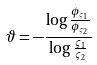Convert formula to latex. <formula><loc_0><loc_0><loc_500><loc_500>\vartheta = - \frac { \log \frac { \phi _ { \varsigma _ { 1 } } } { \phi _ { \varsigma _ { 2 } } } } { \log \frac { \varsigma _ { 1 } } { \varsigma _ { 2 } } }</formula> 